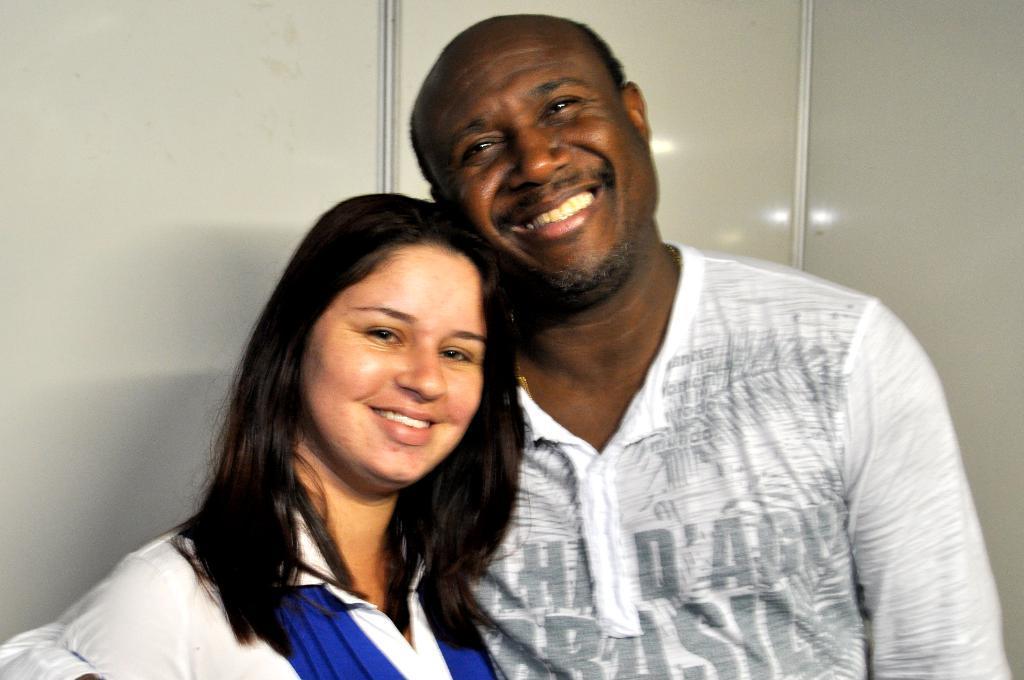Please provide a concise description of this image. In the picture we can see a man and a woman standing together and smiling and man is wearing a white T-shirt and woman is wearing a white dress with some blue color on it and behind them we can see a wall. 